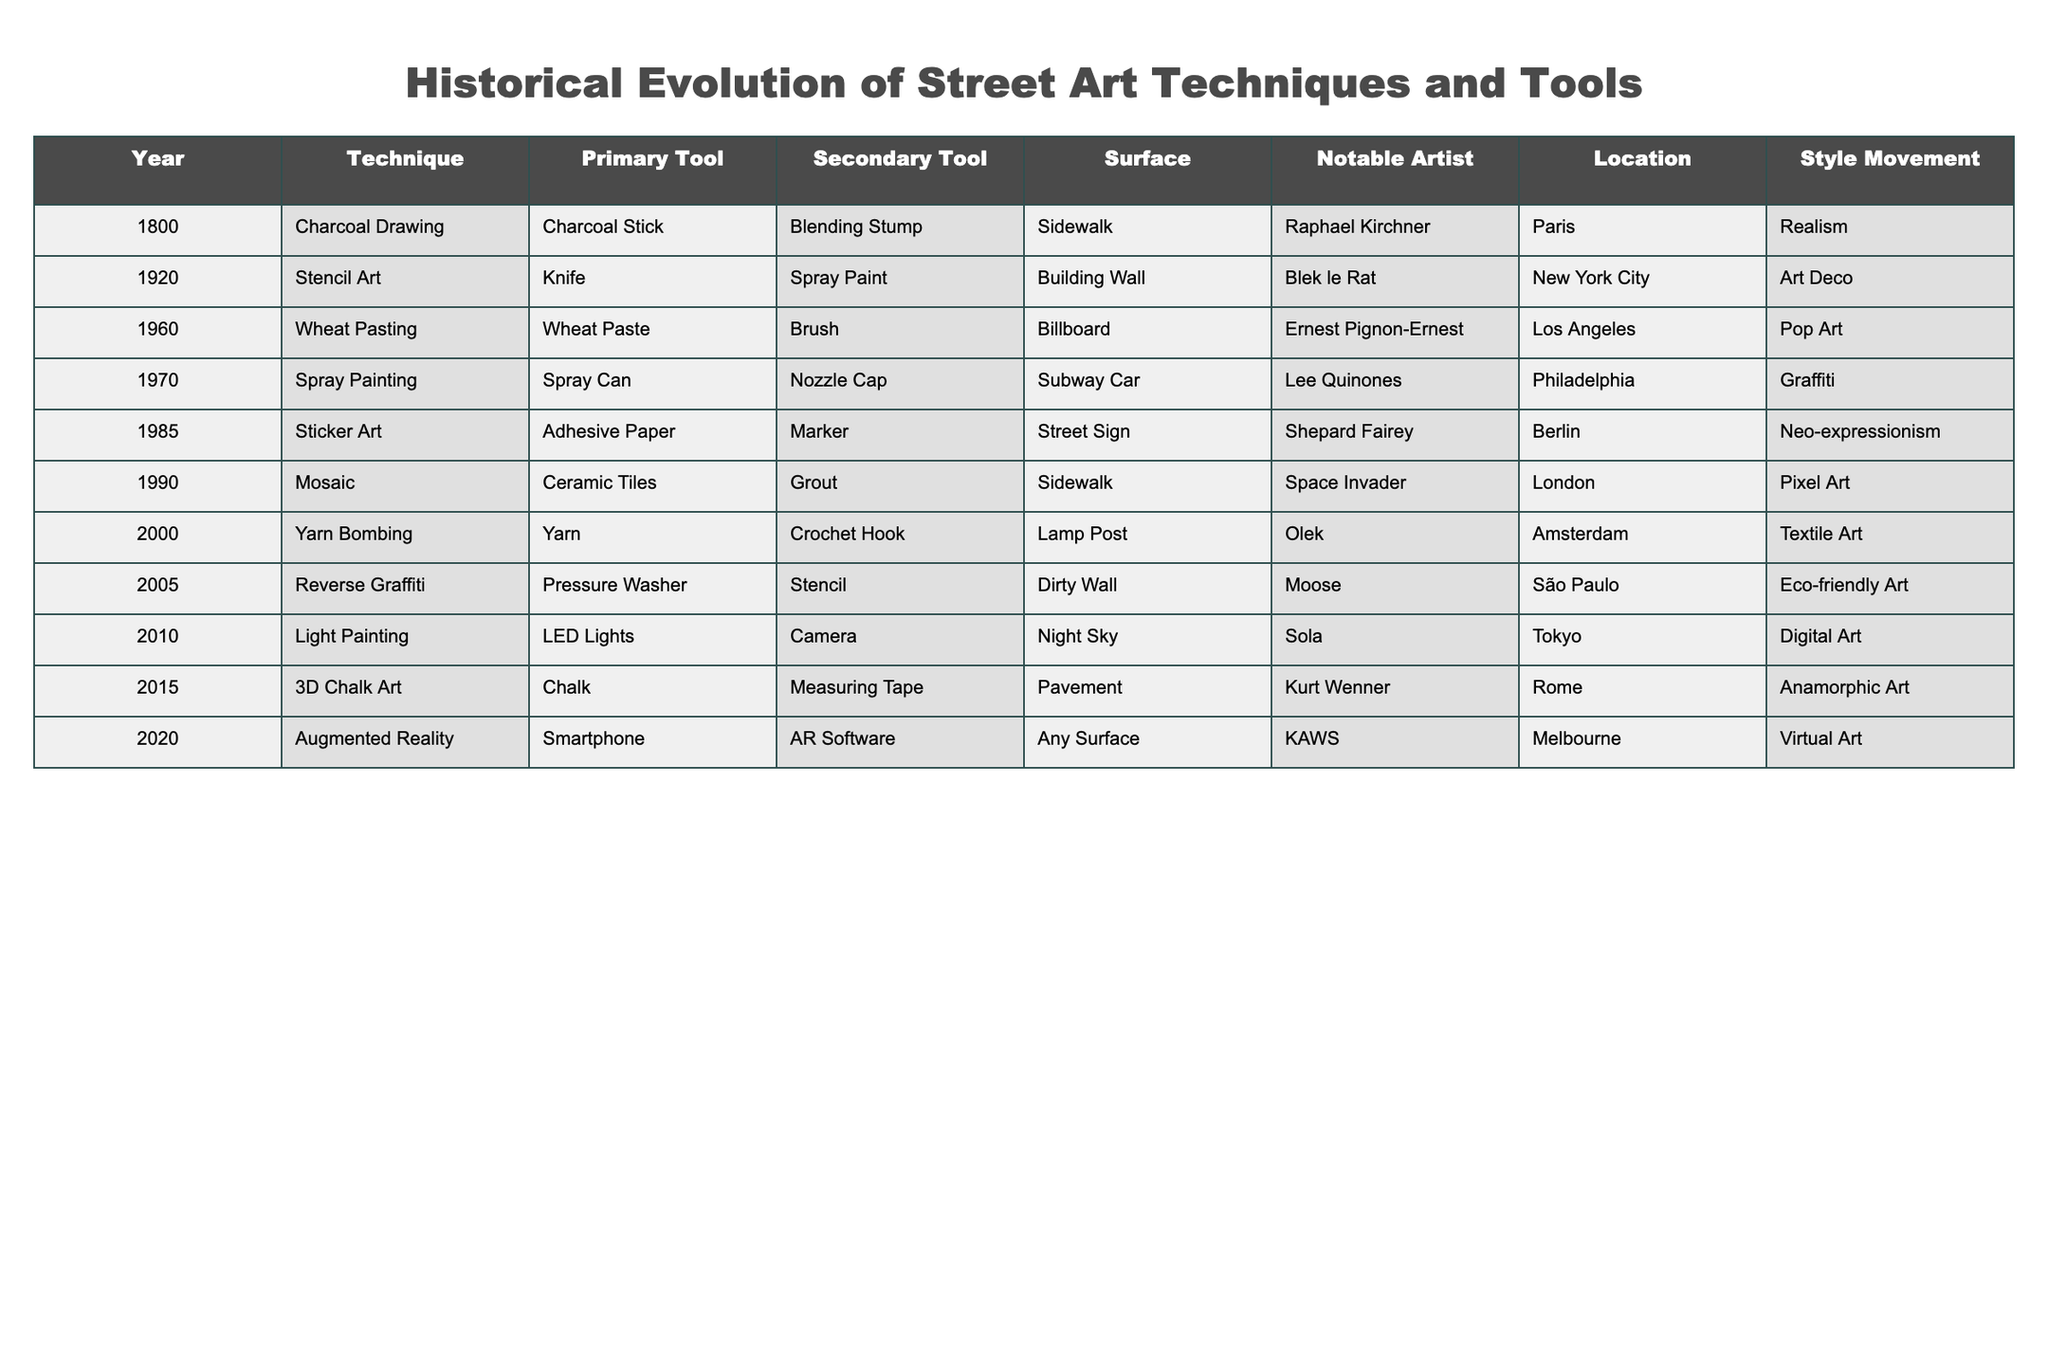What technique was primarily used in 1985? According to the table, the technique used in 1985 is "Sticker Art."
Answer: Sticker Art Who were the notable artists in the 1960s? The table lists "Ernest Pignon-Ernest" as the notable artist for the Wheat Pasting technique in the 1960s.
Answer: Ernest Pignon-Ernest Which technique evolved from using a brush and wheat paste? The technique that evolved from a brush and wheat paste is "Wheat Pasting," used in 1960.
Answer: Wheat Pasting What is the surface used for the technique of Light Painting? The surface used for Light Painting, as stated in the table, is "Night Sky."
Answer: Night Sky Is the primary tool for Mosaic work a ceramic tile? No, the primary tool for Mosaic work is "Ceramic Tiles," not the tiles themselves.
Answer: No How many different surface types are listed in the table? The unique surface types listed are Sidewalk, Building Wall, Billboard, Subway Car, Street Sign, Lamp Post, Dirty Wall, Night Sky, and Pavement, totaling to 9 types.
Answer: 9 Which style movement is associated with the technique of Yarn Bombing? The style movement associated with Yarn Bombing is "Textile Art."
Answer: Textile Art What was the primary tool used for Spray Painting during the 1970s? The primary tool used for Spray Painting in the 1970s is the "Spray Can."
Answer: Spray Can Which year saw the introduction of Augmented Reality in street art? Augmented Reality was introduced in the year 2020 according to the table.
Answer: 2020 Which two techniques make use of a spray can as a primary tool? The table shows that "Stencil Art" (1920) and "Spray Painting" (1970) both use spray cans.
Answer: Two techniques What is the relationship between the location of the notable artist and the technique used in 2000? The notable artist Olek, associated with "Yarn Bombing," is located in Amsterdam in 2000.
Answer: Yarn Bombing in Amsterdam Which techniques predominantly feature urban environments based on their surfaces? The techniques using urban surfaces include "Stencil Art," "Wheat Pasting," "Spray Painting," and "Sticker Art," primarily using walls and signs.
Answer: Four techniques 